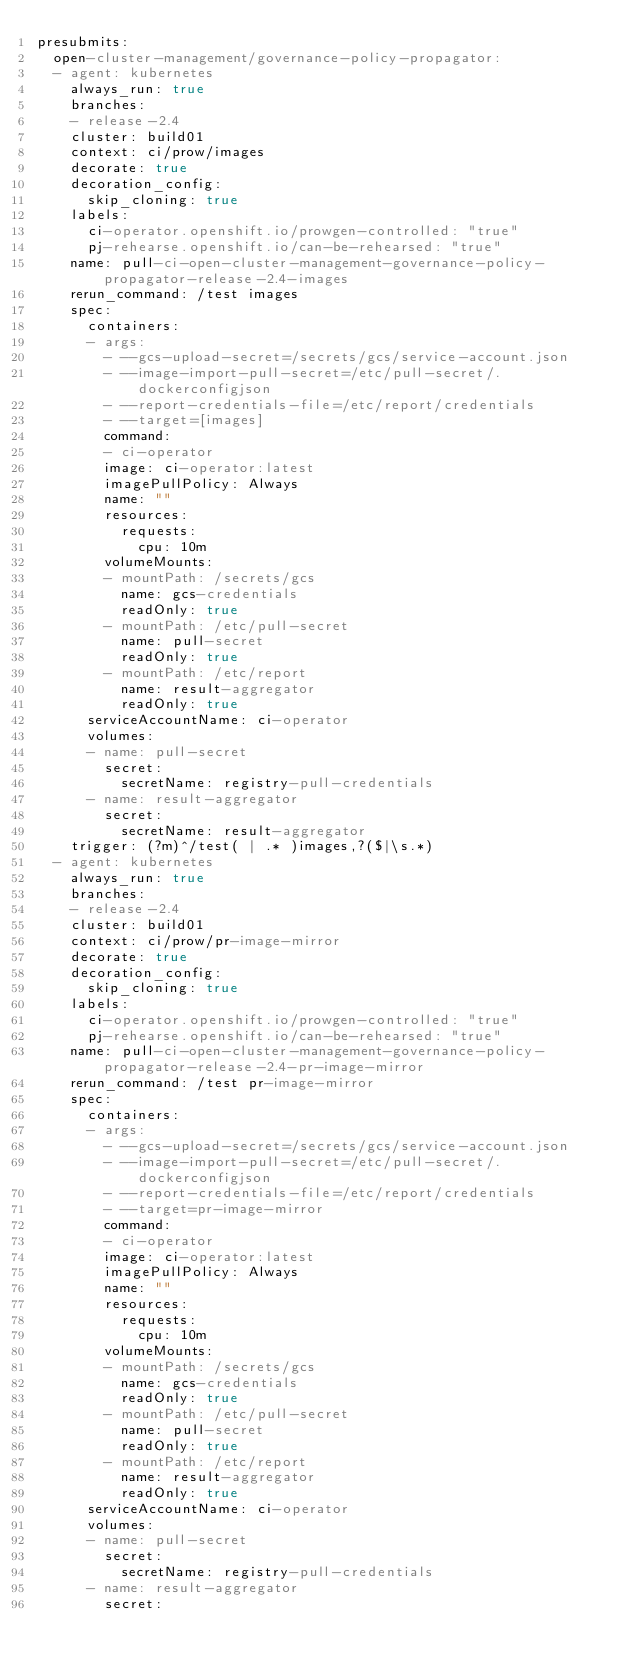Convert code to text. <code><loc_0><loc_0><loc_500><loc_500><_YAML_>presubmits:
  open-cluster-management/governance-policy-propagator:
  - agent: kubernetes
    always_run: true
    branches:
    - release-2.4
    cluster: build01
    context: ci/prow/images
    decorate: true
    decoration_config:
      skip_cloning: true
    labels:
      ci-operator.openshift.io/prowgen-controlled: "true"
      pj-rehearse.openshift.io/can-be-rehearsed: "true"
    name: pull-ci-open-cluster-management-governance-policy-propagator-release-2.4-images
    rerun_command: /test images
    spec:
      containers:
      - args:
        - --gcs-upload-secret=/secrets/gcs/service-account.json
        - --image-import-pull-secret=/etc/pull-secret/.dockerconfigjson
        - --report-credentials-file=/etc/report/credentials
        - --target=[images]
        command:
        - ci-operator
        image: ci-operator:latest
        imagePullPolicy: Always
        name: ""
        resources:
          requests:
            cpu: 10m
        volumeMounts:
        - mountPath: /secrets/gcs
          name: gcs-credentials
          readOnly: true
        - mountPath: /etc/pull-secret
          name: pull-secret
          readOnly: true
        - mountPath: /etc/report
          name: result-aggregator
          readOnly: true
      serviceAccountName: ci-operator
      volumes:
      - name: pull-secret
        secret:
          secretName: registry-pull-credentials
      - name: result-aggregator
        secret:
          secretName: result-aggregator
    trigger: (?m)^/test( | .* )images,?($|\s.*)
  - agent: kubernetes
    always_run: true
    branches:
    - release-2.4
    cluster: build01
    context: ci/prow/pr-image-mirror
    decorate: true
    decoration_config:
      skip_cloning: true
    labels:
      ci-operator.openshift.io/prowgen-controlled: "true"
      pj-rehearse.openshift.io/can-be-rehearsed: "true"
    name: pull-ci-open-cluster-management-governance-policy-propagator-release-2.4-pr-image-mirror
    rerun_command: /test pr-image-mirror
    spec:
      containers:
      - args:
        - --gcs-upload-secret=/secrets/gcs/service-account.json
        - --image-import-pull-secret=/etc/pull-secret/.dockerconfigjson
        - --report-credentials-file=/etc/report/credentials
        - --target=pr-image-mirror
        command:
        - ci-operator
        image: ci-operator:latest
        imagePullPolicy: Always
        name: ""
        resources:
          requests:
            cpu: 10m
        volumeMounts:
        - mountPath: /secrets/gcs
          name: gcs-credentials
          readOnly: true
        - mountPath: /etc/pull-secret
          name: pull-secret
          readOnly: true
        - mountPath: /etc/report
          name: result-aggregator
          readOnly: true
      serviceAccountName: ci-operator
      volumes:
      - name: pull-secret
        secret:
          secretName: registry-pull-credentials
      - name: result-aggregator
        secret:</code> 